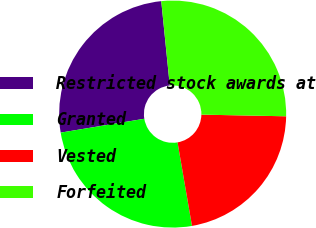<chart> <loc_0><loc_0><loc_500><loc_500><pie_chart><fcel>Restricted stock awards at<fcel>Granted<fcel>Vested<fcel>Forfeited<nl><fcel>26.01%<fcel>25.11%<fcel>21.96%<fcel>26.91%<nl></chart> 